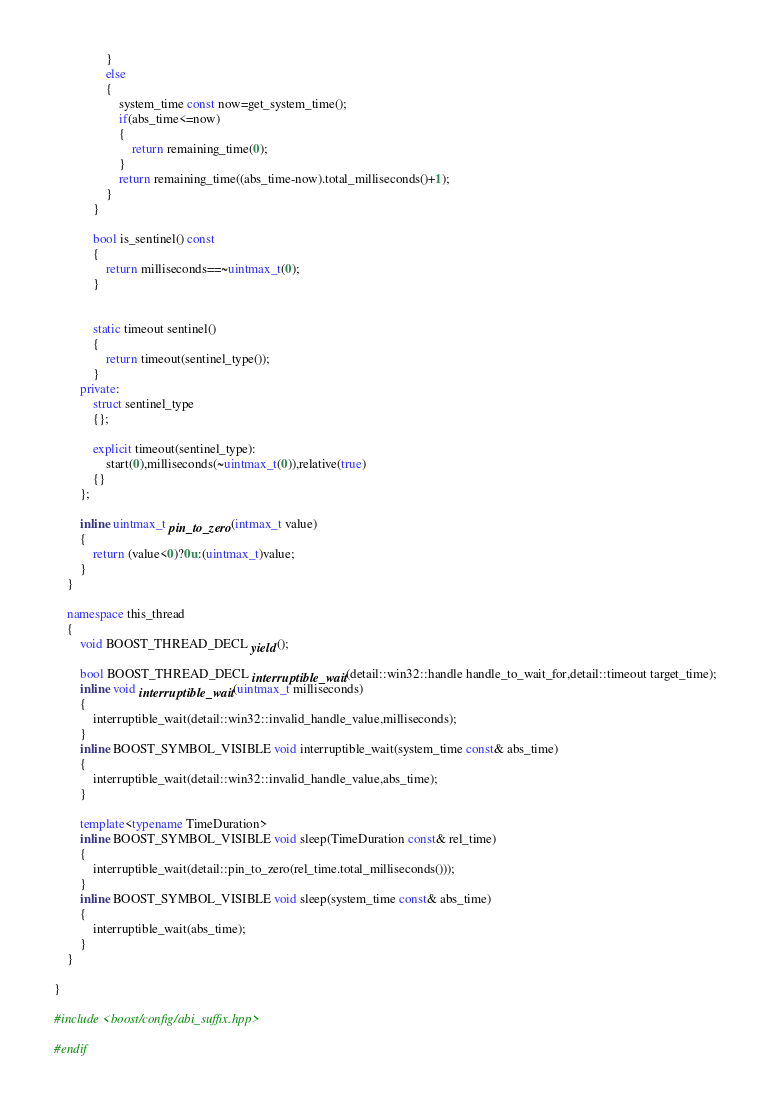Convert code to text. <code><loc_0><loc_0><loc_500><loc_500><_C++_>                }
                else
                {
                    system_time const now=get_system_time();
                    if(abs_time<=now)
                    {
                        return remaining_time(0);
                    }
                    return remaining_time((abs_time-now).total_milliseconds()+1);
                }
            }

            bool is_sentinel() const
            {
                return milliseconds==~uintmax_t(0);
            }


            static timeout sentinel()
            {
                return timeout(sentinel_type());
            }
        private:
            struct sentinel_type
            {};

            explicit timeout(sentinel_type):
                start(0),milliseconds(~uintmax_t(0)),relative(true)
            {}
        };

        inline uintmax_t pin_to_zero(intmax_t value)
        {
            return (value<0)?0u:(uintmax_t)value;
        }
    }

    namespace this_thread
    {
        void BOOST_THREAD_DECL yield();

        bool BOOST_THREAD_DECL interruptible_wait(detail::win32::handle handle_to_wait_for,detail::timeout target_time);
        inline void interruptible_wait(uintmax_t milliseconds)
        {
            interruptible_wait(detail::win32::invalid_handle_value,milliseconds);
        }
        inline BOOST_SYMBOL_VISIBLE void interruptible_wait(system_time const& abs_time)
        {
            interruptible_wait(detail::win32::invalid_handle_value,abs_time);
        }

        template<typename TimeDuration>
        inline BOOST_SYMBOL_VISIBLE void sleep(TimeDuration const& rel_time)
        {
            interruptible_wait(detail::pin_to_zero(rel_time.total_milliseconds()));
        }
        inline BOOST_SYMBOL_VISIBLE void sleep(system_time const& abs_time)
        {
            interruptible_wait(abs_time);
        }
    }

}

#include <boost/config/abi_suffix.hpp>

#endif
</code> 